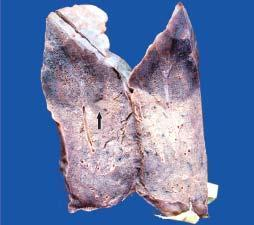does electron microscopy show dark tan firm areas with base on the pleura?
Answer the question using a single word or phrase. No 